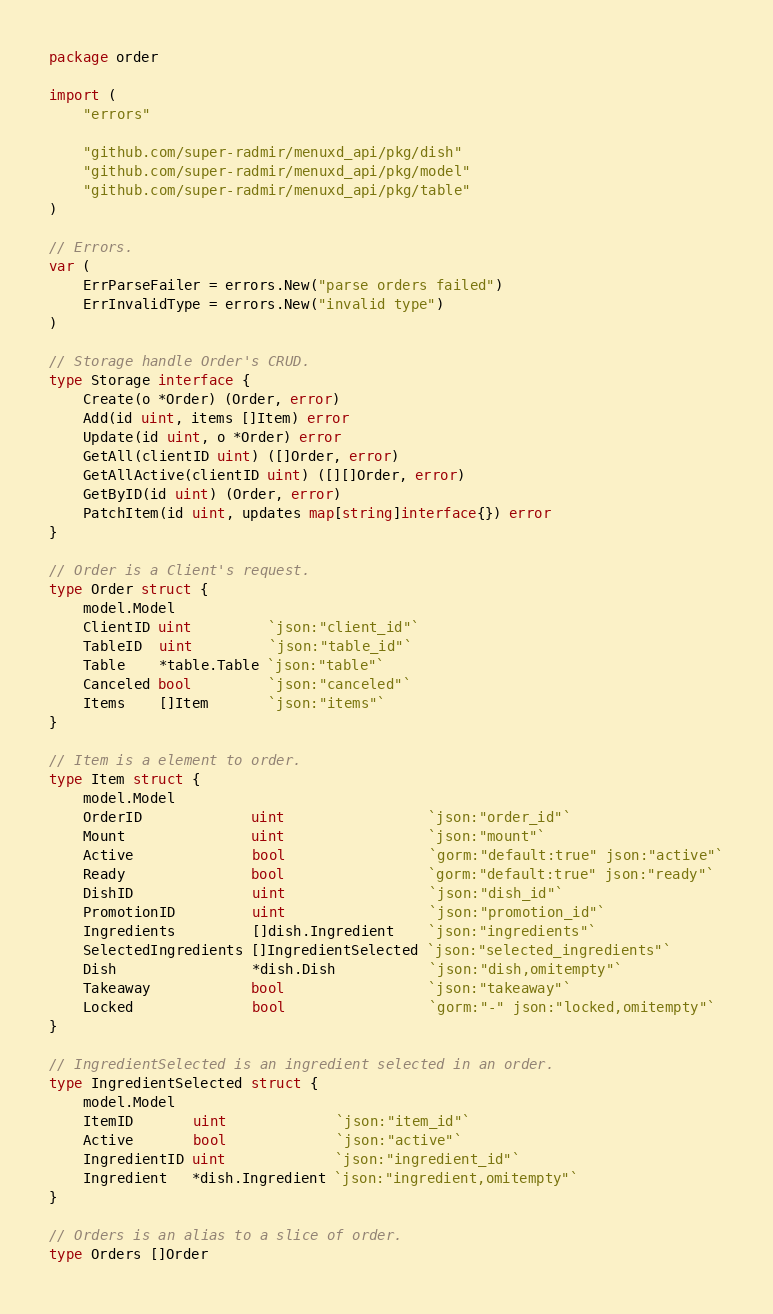<code> <loc_0><loc_0><loc_500><loc_500><_Go_>package order

import (
	"errors"

	"github.com/super-radmir/menuxd_api/pkg/dish"
	"github.com/super-radmir/menuxd_api/pkg/model"
	"github.com/super-radmir/menuxd_api/pkg/table"
)

// Errors.
var (
	ErrParseFailer = errors.New("parse orders failed")
	ErrInvalidType = errors.New("invalid type")
)

// Storage handle Order's CRUD.
type Storage interface {
	Create(o *Order) (Order, error)
	Add(id uint, items []Item) error
	Update(id uint, o *Order) error
	GetAll(clientID uint) ([]Order, error)
	GetAllActive(clientID uint) ([][]Order, error)
	GetByID(id uint) (Order, error)
	PatchItem(id uint, updates map[string]interface{}) error
}

// Order is a Client's request.
type Order struct {
	model.Model
	ClientID uint         `json:"client_id"`
	TableID  uint         `json:"table_id"`
	Table    *table.Table `json:"table"`
	Canceled bool         `json:"canceled"`
	Items    []Item       `json:"items"`
}

// Item is a element to order.
type Item struct {
	model.Model
	OrderID             uint                 `json:"order_id"`
	Mount               uint                 `json:"mount"`
	Active              bool                 `gorm:"default:true" json:"active"`
	Ready               bool                 `gorm:"default:true" json:"ready"`
	DishID              uint                 `json:"dish_id"`
	PromotionID         uint                 `json:"promotion_id"`
	Ingredients         []dish.Ingredient    `json:"ingredients"`
	SelectedIngredients []IngredientSelected `json:"selected_ingredients"`
	Dish                *dish.Dish           `json:"dish,omitempty"`
	Takeaway            bool                 `json:"takeaway"`
	Locked              bool                 `gorm:"-" json:"locked,omitempty"`
}

// IngredientSelected is an ingredient selected in an order.
type IngredientSelected struct {
	model.Model
	ItemID       uint             `json:"item_id"`
	Active       bool             `json:"active"`
	IngredientID uint             `json:"ingredient_id"`
	Ingredient   *dish.Ingredient `json:"ingredient,omitempty"`
}

// Orders is an alias to a slice of order.
type Orders []Order
</code> 